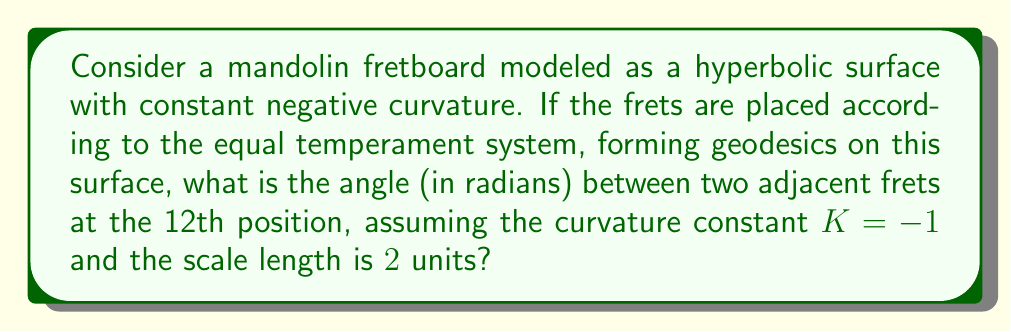Can you answer this question? Let's approach this step-by-step:

1) In hyperbolic geometry, the distance $d$ between two points on a geodesic is related to the angle $\theta$ between them (measured from the center of curvature) by the formula:

   $$\cosh(\sqrt{-K}d) = \cosh(\theta)$$

2) Given $K = -1$, this simplifies to:

   $$\cosh(d) = \cosh(\theta)$$

3) The scale length is 2 units, so the 12th fret is at 1 unit (halfway).

4) In equal temperament, each semitone represents a frequency ratio of $2^{1/12}$. The distance ratio between adjacent frets is therefore also $2^{1/12}$.

5) At the 12th fret, the distance between adjacent frets is:

   $$d = 1 - 1 \cdot 2^{-1/12} \approx 0.0577$$

6) Substituting this into our equation:

   $$\cosh(0.0577) = \cosh(\theta)$$

7) To solve for $\theta$, we apply $\text{arcosh}$ to both sides:

   $$\theta = \text{arcosh}(\cosh(0.0577))$$

8) This simplifies back to:

   $$\theta \approx 0.0577 \text{ radians}$$

This angle represents the hyperbolic angle between adjacent frets at the 12th position on our non-Euclidean mandolin fretboard.
Answer: $0.0577$ radians 